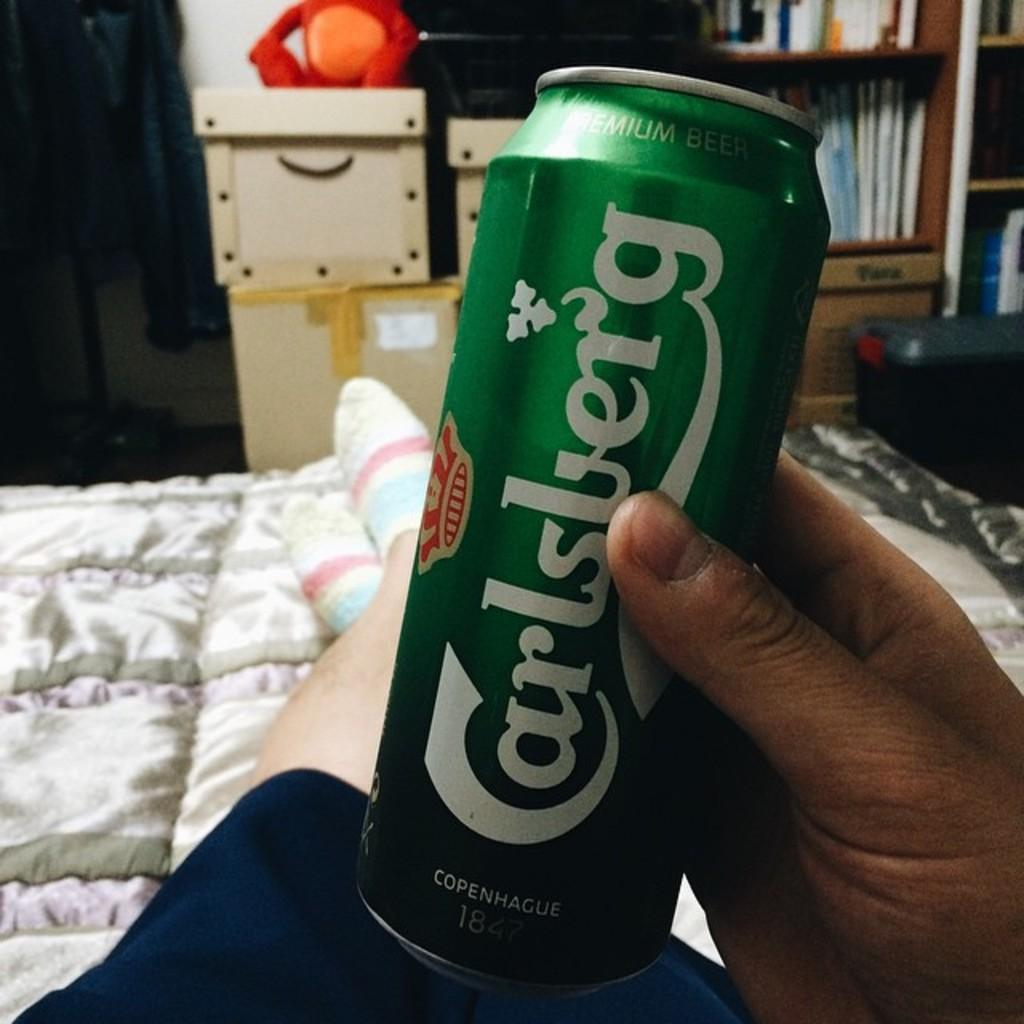<image>
Present a compact description of the photo's key features. A person relaxing in bed holds a Carlsberg can. 